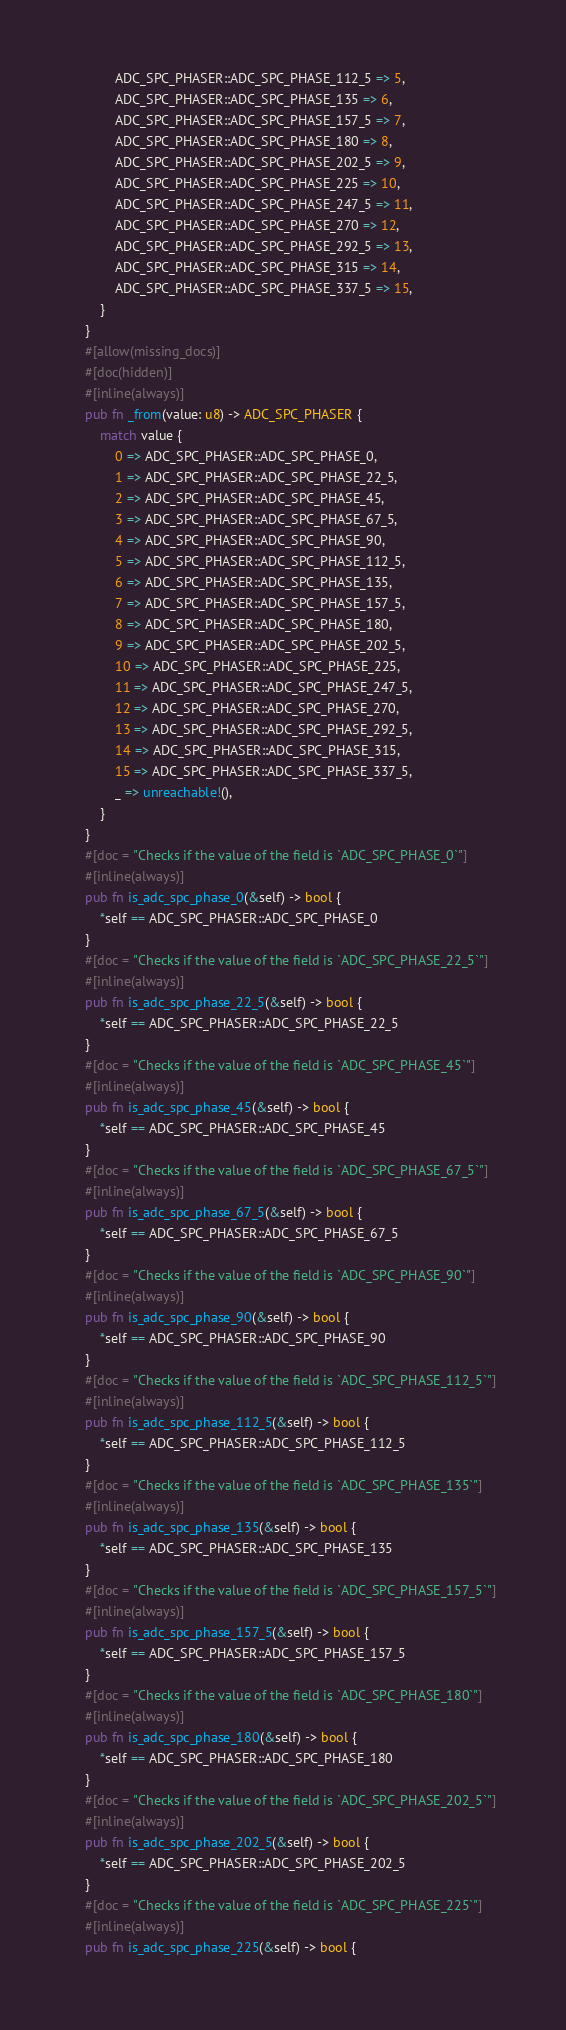<code> <loc_0><loc_0><loc_500><loc_500><_Rust_>            ADC_SPC_PHASER::ADC_SPC_PHASE_112_5 => 5,
            ADC_SPC_PHASER::ADC_SPC_PHASE_135 => 6,
            ADC_SPC_PHASER::ADC_SPC_PHASE_157_5 => 7,
            ADC_SPC_PHASER::ADC_SPC_PHASE_180 => 8,
            ADC_SPC_PHASER::ADC_SPC_PHASE_202_5 => 9,
            ADC_SPC_PHASER::ADC_SPC_PHASE_225 => 10,
            ADC_SPC_PHASER::ADC_SPC_PHASE_247_5 => 11,
            ADC_SPC_PHASER::ADC_SPC_PHASE_270 => 12,
            ADC_SPC_PHASER::ADC_SPC_PHASE_292_5 => 13,
            ADC_SPC_PHASER::ADC_SPC_PHASE_315 => 14,
            ADC_SPC_PHASER::ADC_SPC_PHASE_337_5 => 15,
        }
    }
    #[allow(missing_docs)]
    #[doc(hidden)]
    #[inline(always)]
    pub fn _from(value: u8) -> ADC_SPC_PHASER {
        match value {
            0 => ADC_SPC_PHASER::ADC_SPC_PHASE_0,
            1 => ADC_SPC_PHASER::ADC_SPC_PHASE_22_5,
            2 => ADC_SPC_PHASER::ADC_SPC_PHASE_45,
            3 => ADC_SPC_PHASER::ADC_SPC_PHASE_67_5,
            4 => ADC_SPC_PHASER::ADC_SPC_PHASE_90,
            5 => ADC_SPC_PHASER::ADC_SPC_PHASE_112_5,
            6 => ADC_SPC_PHASER::ADC_SPC_PHASE_135,
            7 => ADC_SPC_PHASER::ADC_SPC_PHASE_157_5,
            8 => ADC_SPC_PHASER::ADC_SPC_PHASE_180,
            9 => ADC_SPC_PHASER::ADC_SPC_PHASE_202_5,
            10 => ADC_SPC_PHASER::ADC_SPC_PHASE_225,
            11 => ADC_SPC_PHASER::ADC_SPC_PHASE_247_5,
            12 => ADC_SPC_PHASER::ADC_SPC_PHASE_270,
            13 => ADC_SPC_PHASER::ADC_SPC_PHASE_292_5,
            14 => ADC_SPC_PHASER::ADC_SPC_PHASE_315,
            15 => ADC_SPC_PHASER::ADC_SPC_PHASE_337_5,
            _ => unreachable!(),
        }
    }
    #[doc = "Checks if the value of the field is `ADC_SPC_PHASE_0`"]
    #[inline(always)]
    pub fn is_adc_spc_phase_0(&self) -> bool {
        *self == ADC_SPC_PHASER::ADC_SPC_PHASE_0
    }
    #[doc = "Checks if the value of the field is `ADC_SPC_PHASE_22_5`"]
    #[inline(always)]
    pub fn is_adc_spc_phase_22_5(&self) -> bool {
        *self == ADC_SPC_PHASER::ADC_SPC_PHASE_22_5
    }
    #[doc = "Checks if the value of the field is `ADC_SPC_PHASE_45`"]
    #[inline(always)]
    pub fn is_adc_spc_phase_45(&self) -> bool {
        *self == ADC_SPC_PHASER::ADC_SPC_PHASE_45
    }
    #[doc = "Checks if the value of the field is `ADC_SPC_PHASE_67_5`"]
    #[inline(always)]
    pub fn is_adc_spc_phase_67_5(&self) -> bool {
        *self == ADC_SPC_PHASER::ADC_SPC_PHASE_67_5
    }
    #[doc = "Checks if the value of the field is `ADC_SPC_PHASE_90`"]
    #[inline(always)]
    pub fn is_adc_spc_phase_90(&self) -> bool {
        *self == ADC_SPC_PHASER::ADC_SPC_PHASE_90
    }
    #[doc = "Checks if the value of the field is `ADC_SPC_PHASE_112_5`"]
    #[inline(always)]
    pub fn is_adc_spc_phase_112_5(&self) -> bool {
        *self == ADC_SPC_PHASER::ADC_SPC_PHASE_112_5
    }
    #[doc = "Checks if the value of the field is `ADC_SPC_PHASE_135`"]
    #[inline(always)]
    pub fn is_adc_spc_phase_135(&self) -> bool {
        *self == ADC_SPC_PHASER::ADC_SPC_PHASE_135
    }
    #[doc = "Checks if the value of the field is `ADC_SPC_PHASE_157_5`"]
    #[inline(always)]
    pub fn is_adc_spc_phase_157_5(&self) -> bool {
        *self == ADC_SPC_PHASER::ADC_SPC_PHASE_157_5
    }
    #[doc = "Checks if the value of the field is `ADC_SPC_PHASE_180`"]
    #[inline(always)]
    pub fn is_adc_spc_phase_180(&self) -> bool {
        *self == ADC_SPC_PHASER::ADC_SPC_PHASE_180
    }
    #[doc = "Checks if the value of the field is `ADC_SPC_PHASE_202_5`"]
    #[inline(always)]
    pub fn is_adc_spc_phase_202_5(&self) -> bool {
        *self == ADC_SPC_PHASER::ADC_SPC_PHASE_202_5
    }
    #[doc = "Checks if the value of the field is `ADC_SPC_PHASE_225`"]
    #[inline(always)]
    pub fn is_adc_spc_phase_225(&self) -> bool {</code> 